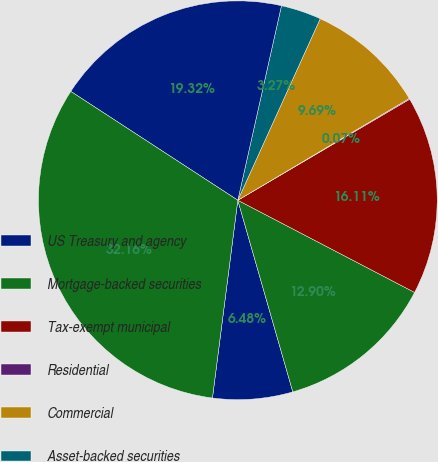Convert chart to OTSL. <chart><loc_0><loc_0><loc_500><loc_500><pie_chart><fcel>US Treasury and agency<fcel>Mortgage-backed securities<fcel>Tax-exempt municipal<fcel>Residential<fcel>Commercial<fcel>Asset-backed securities<fcel>Corporate debt securities<fcel>Total debt securities<nl><fcel>6.48%<fcel>12.9%<fcel>16.11%<fcel>0.07%<fcel>9.69%<fcel>3.27%<fcel>19.32%<fcel>32.16%<nl></chart> 